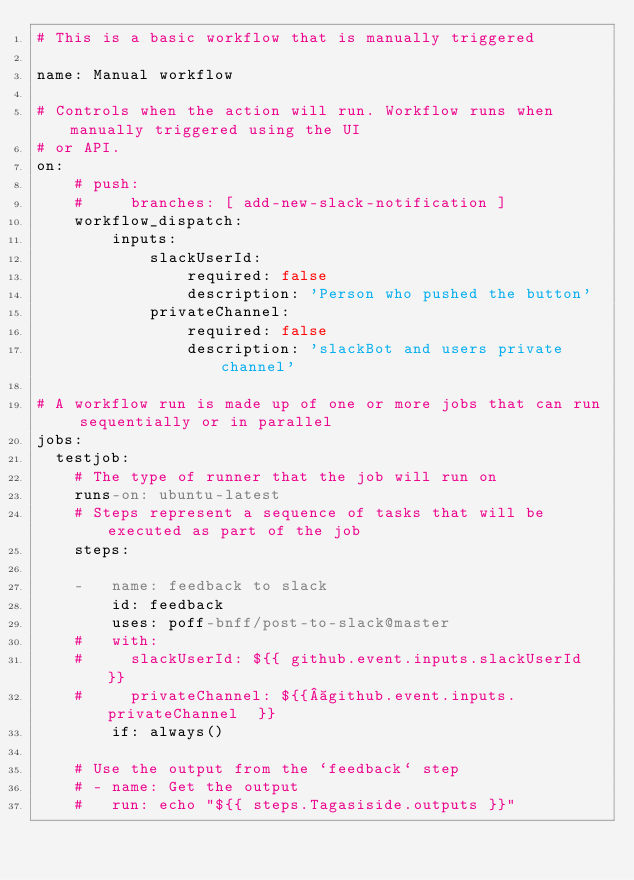Convert code to text. <code><loc_0><loc_0><loc_500><loc_500><_YAML_># This is a basic workflow that is manually triggered

name: Manual workflow

# Controls when the action will run. Workflow runs when manually triggered using the UI
# or API.
on:
    # push:
    #     branches: [ add-new-slack-notification ]
    workflow_dispatch:
        inputs:
            slackUserId:
                required: false
                description: 'Person who pushed the button'
            privateChannel:
                required: false
                description: 'slackBot and users private channel'

# A workflow run is made up of one or more jobs that can run sequentially or in parallel
jobs:
  testjob:
    # The type of runner that the job will run on
    runs-on: ubuntu-latest
    # Steps represent a sequence of tasks that will be executed as part of the job
    steps:

    -   name: feedback to slack
        id: feedback
        uses: poff-bnff/post-to-slack@master
    #   with:
    #     slackUserId: ${{ github.event.inputs.slackUserId }}
    #     privateChannel: ${{ github.event.inputs.privateChannel  }}
        if: always()

    # Use the output from the `feedback` step
    # - name: Get the output
    #   run: echo "${{ steps.Tagasiside.outputs }}"
</code> 